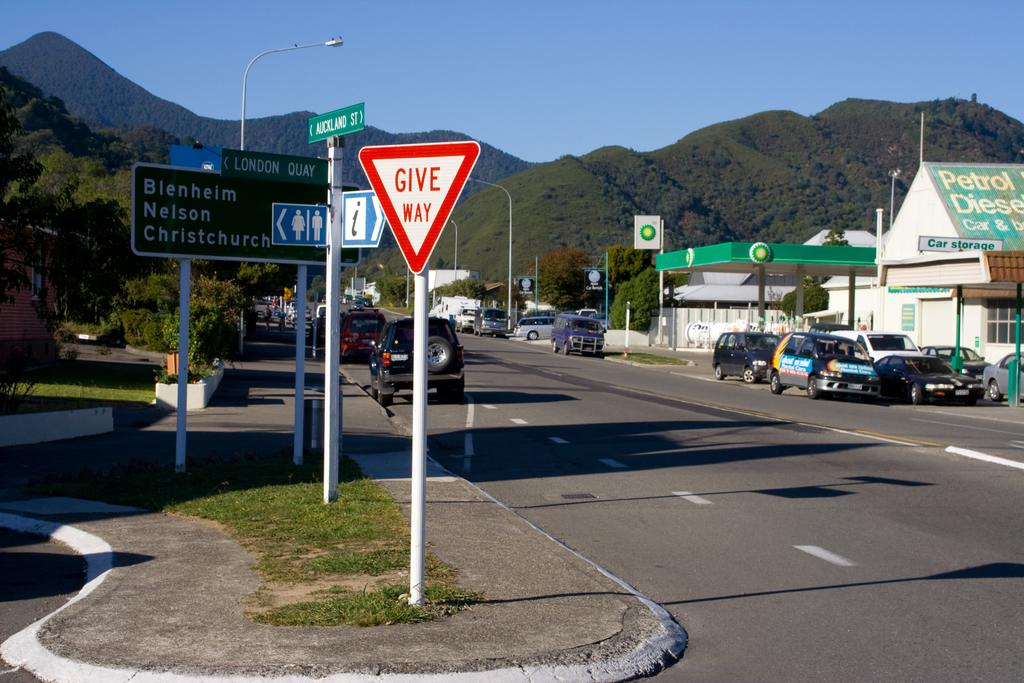Provide a one-sentence caption for the provided image. a give way sign that is red in color and outside. 